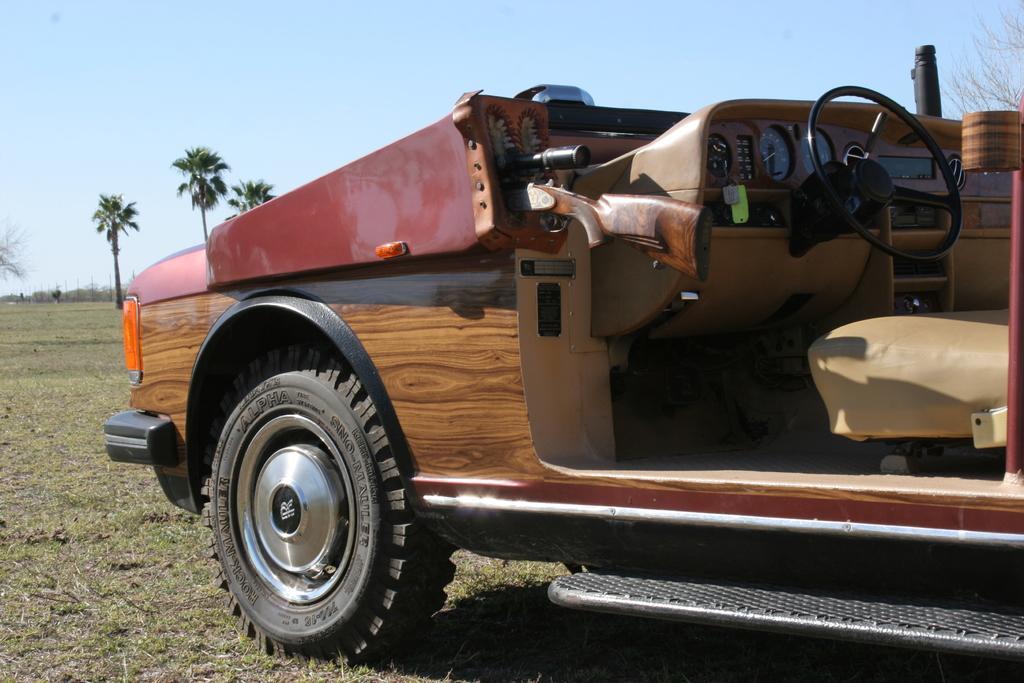In one or two sentences, can you explain what this image depicts? In this image we can see a vehicle. There are few trees at the left side of the image. We can see the sky in the image. There is a grassy land in the image. 